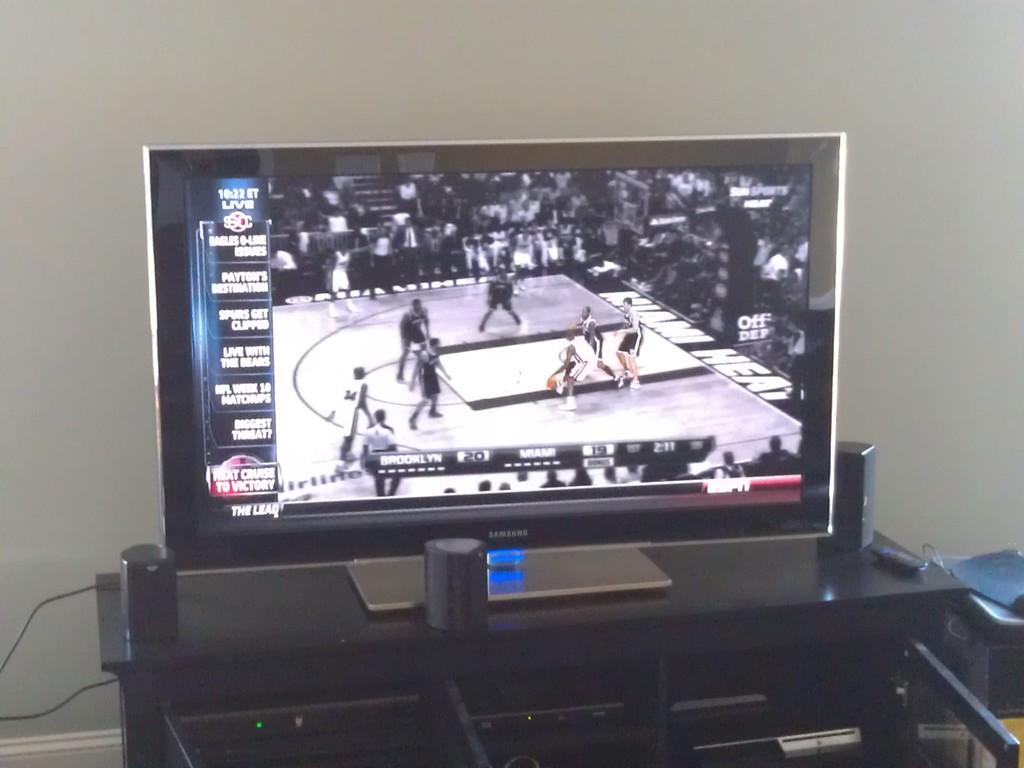What is the score of the brooklyn and miami game?
Offer a terse response. 20-19. What time does it say in the upper left corner of the tv screen?
Provide a short and direct response. 10:22. 